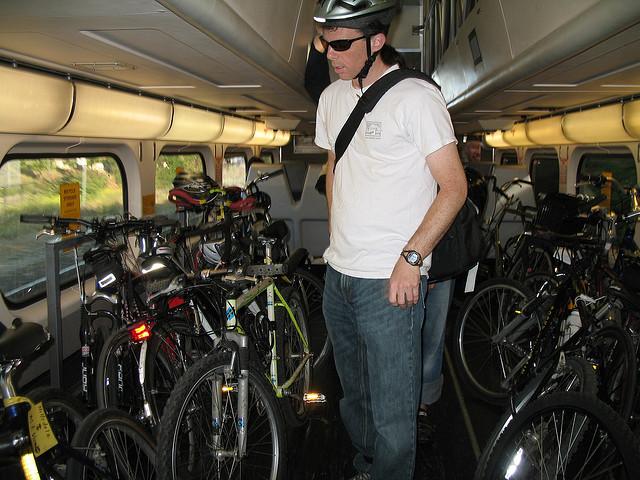Are the bikes on a train?
Concise answer only. Yes. Is the man standing near bicycles?
Answer briefly. Yes. What color is the man's shirt?
Quick response, please. White. 